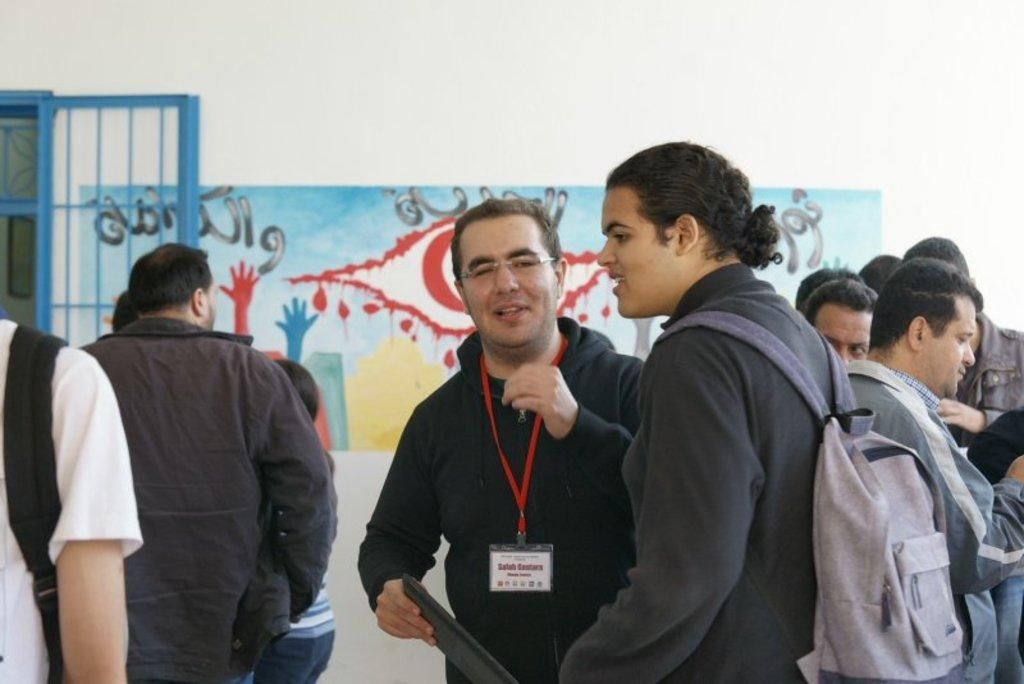What are the people in the image doing? The persons standing on the floor in the image are likely engaged in some activity or standing in a particular location. What can be seen on the wall in the image? There is a painting on the wall in the image. What architectural feature is visible in the image? There is a window in the image. What type of farm animals can be seen grazing in the image? There is no farm or farm animals present in the image. What kind of apparatus is being used by the persons in the image? The provided facts do not mention any specific apparatus being used by the persons in the image. 